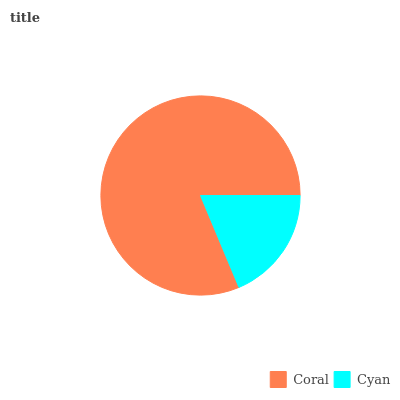Is Cyan the minimum?
Answer yes or no. Yes. Is Coral the maximum?
Answer yes or no. Yes. Is Cyan the maximum?
Answer yes or no. No. Is Coral greater than Cyan?
Answer yes or no. Yes. Is Cyan less than Coral?
Answer yes or no. Yes. Is Cyan greater than Coral?
Answer yes or no. No. Is Coral less than Cyan?
Answer yes or no. No. Is Coral the high median?
Answer yes or no. Yes. Is Cyan the low median?
Answer yes or no. Yes. Is Cyan the high median?
Answer yes or no. No. Is Coral the low median?
Answer yes or no. No. 